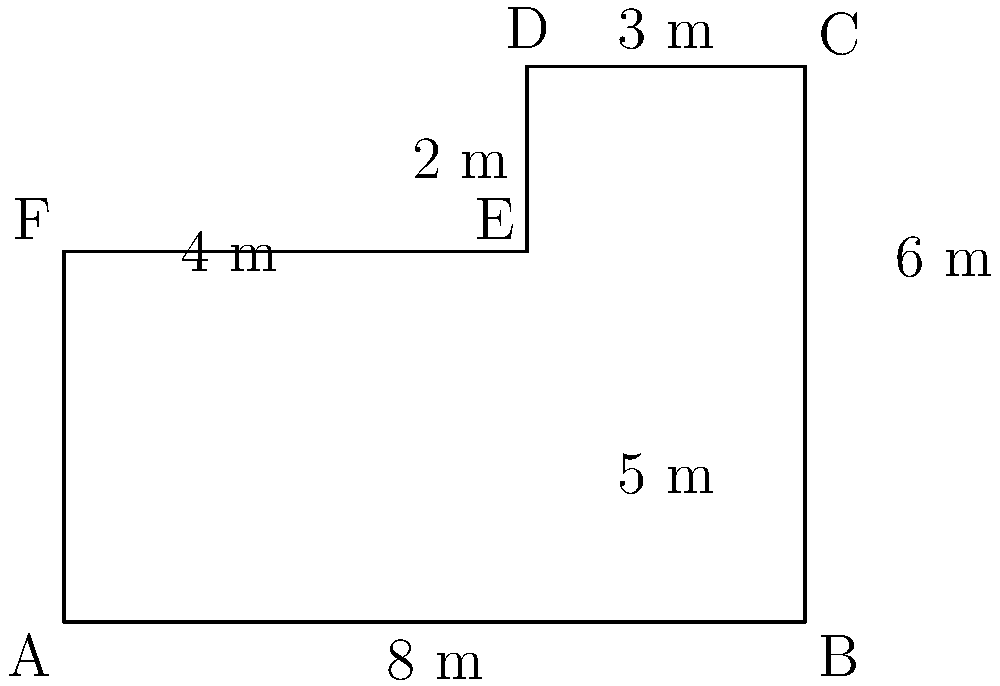You're planning to replace the flooring in your school library. The library has an irregular shape as shown in the diagram. Calculate the total area of the library floor in square meters. To calculate the area of this irregularly shaped library floor, we can divide it into two rectangles:

1. Rectangle ABEF:
   Length = 8 m
   Width = 4 m
   Area of ABEF = $8 \times 4 = 32$ m²

2. Rectangle DCDE:
   Length = 3 m
   Width = 2 m
   Area of DCDE = $3 \times 2 = 6$ m²

Total area of the library floor:
$$\text{Total Area} = \text{Area of ABEF} + \text{Area of DCDE}$$
$$\text{Total Area} = 32 \text{ m}² + 6 \text{ m}² = 38 \text{ m}²$$

Therefore, the total area of the library floor is 38 square meters.
Answer: 38 m² 